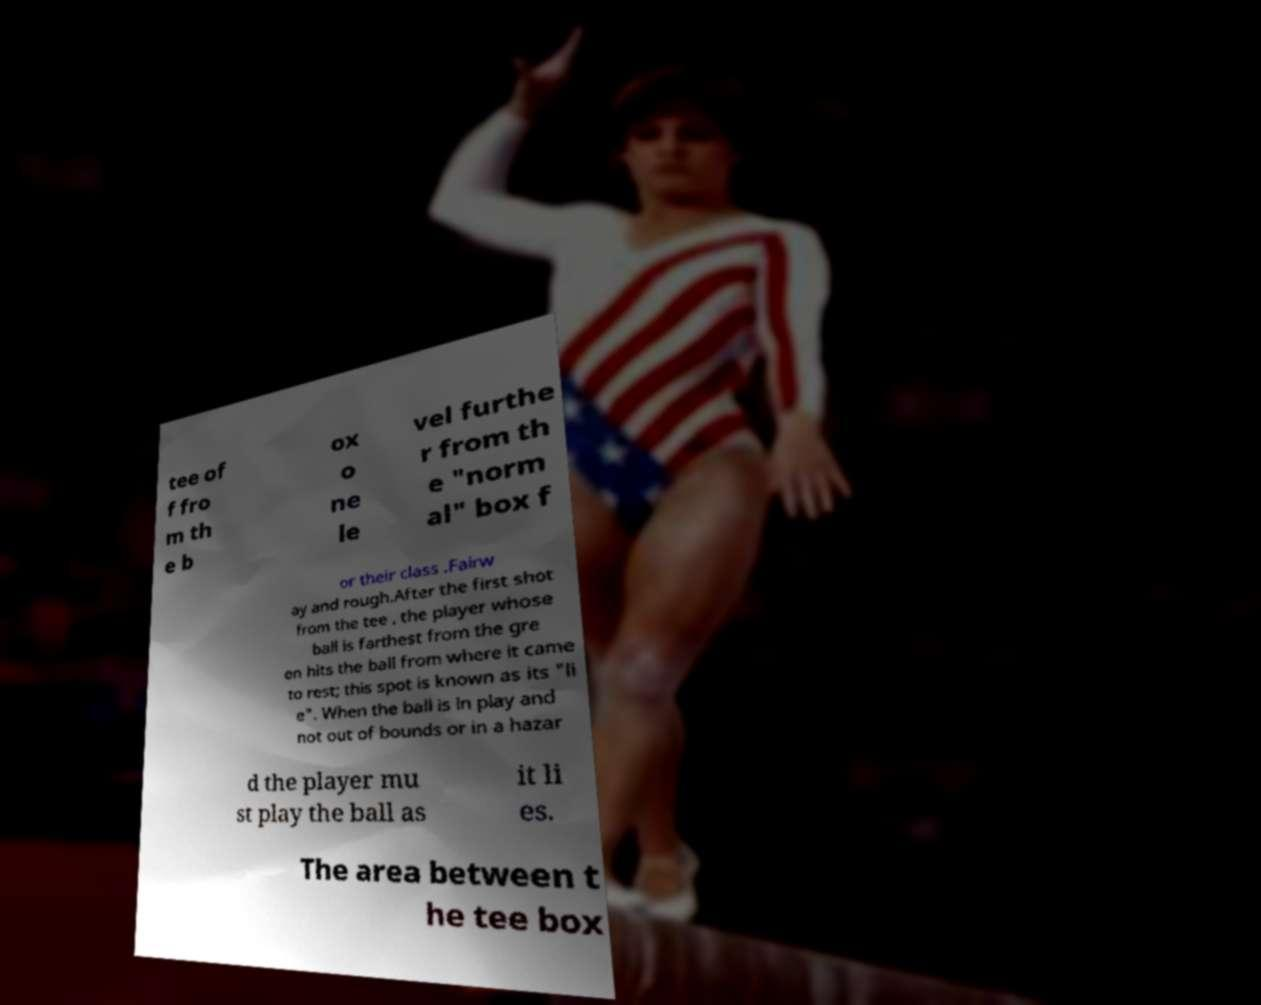Could you extract and type out the text from this image? tee of f fro m th e b ox o ne le vel furthe r from th e "norm al" box f or their class .Fairw ay and rough.After the first shot from the tee , the player whose ball is farthest from the gre en hits the ball from where it came to rest; this spot is known as its "li e". When the ball is in play and not out of bounds or in a hazar d the player mu st play the ball as it li es. The area between t he tee box 